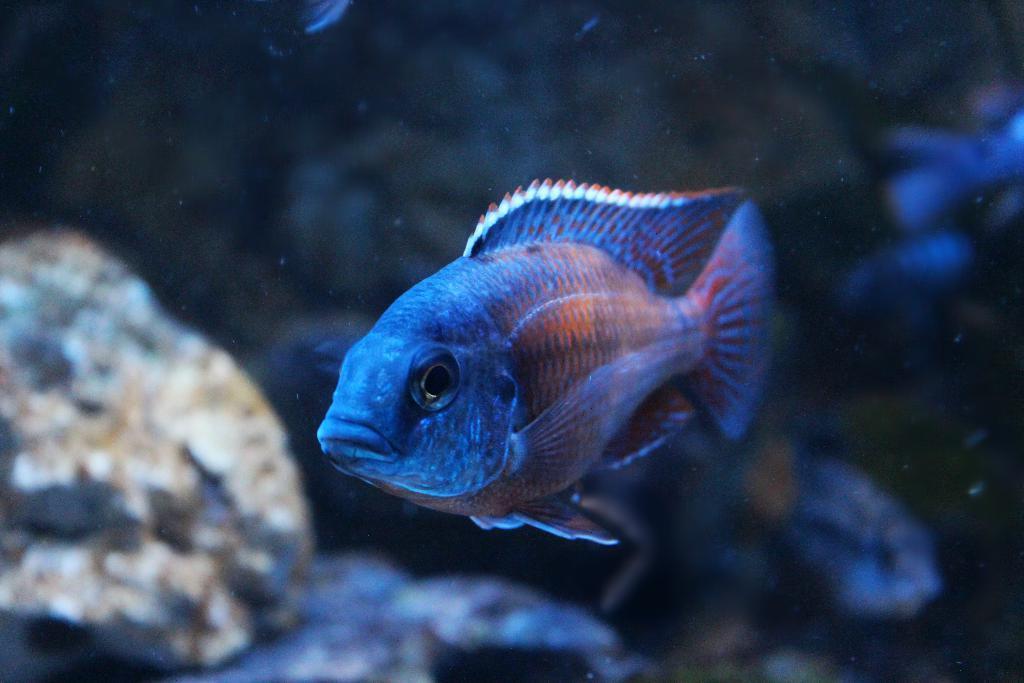Please provide a concise description of this image. In this image we can see a fish in water. To the left side of the image we can see some rocks. 